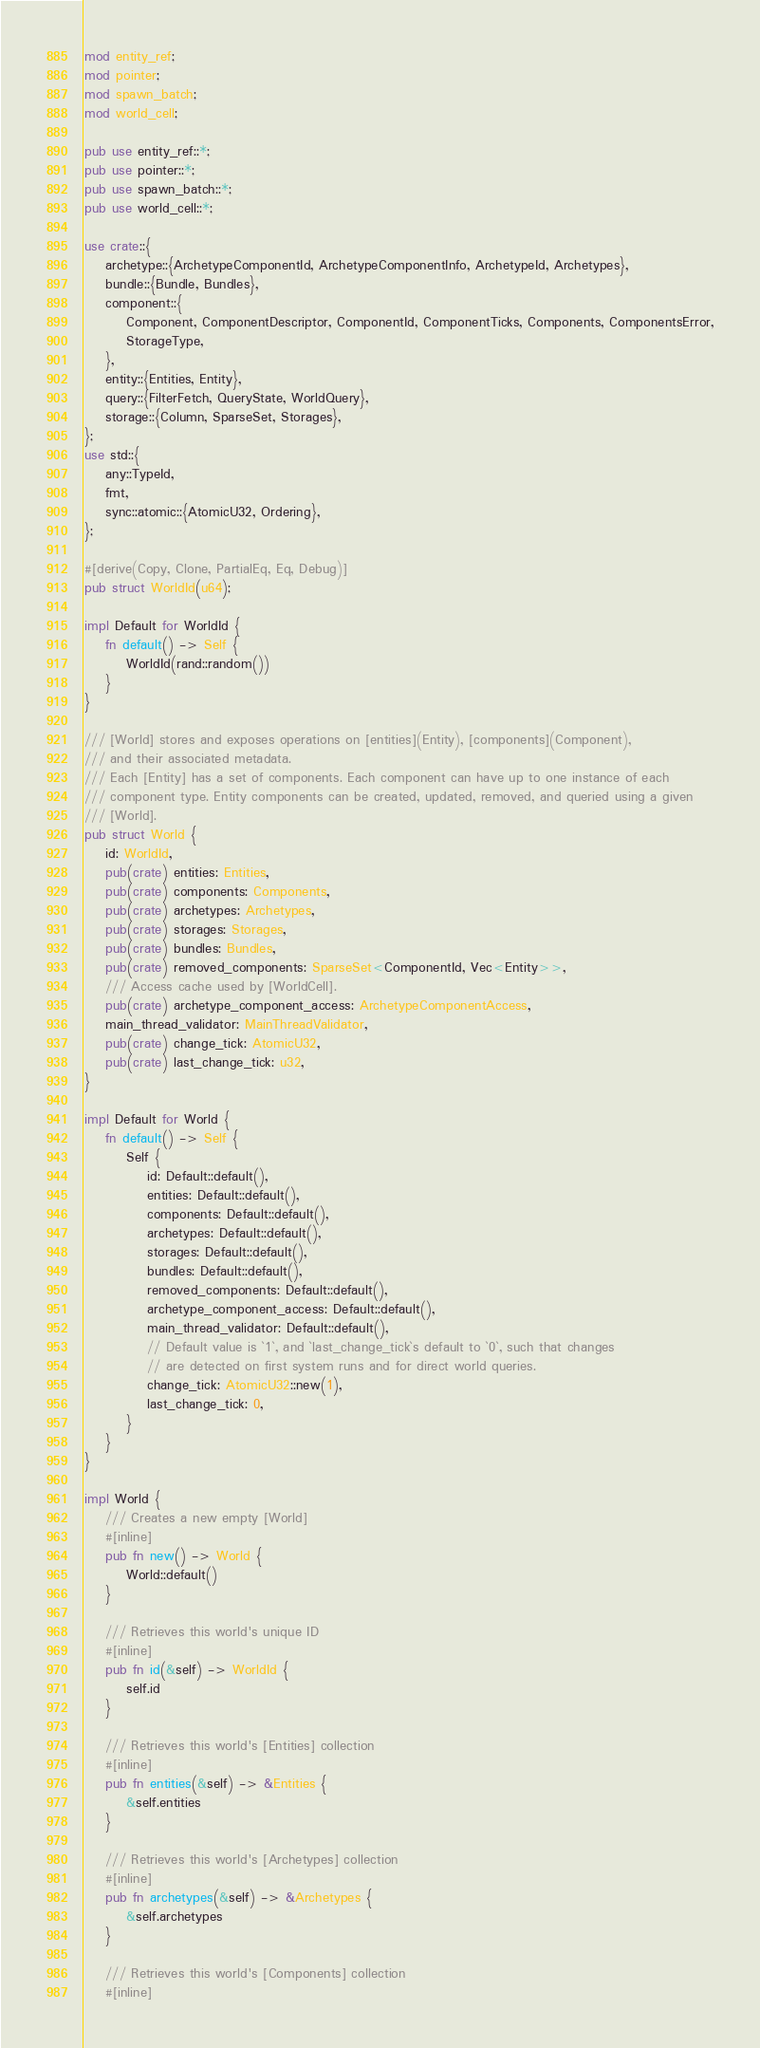<code> <loc_0><loc_0><loc_500><loc_500><_Rust_>mod entity_ref;
mod pointer;
mod spawn_batch;
mod world_cell;

pub use entity_ref::*;
pub use pointer::*;
pub use spawn_batch::*;
pub use world_cell::*;

use crate::{
    archetype::{ArchetypeComponentId, ArchetypeComponentInfo, ArchetypeId, Archetypes},
    bundle::{Bundle, Bundles},
    component::{
        Component, ComponentDescriptor, ComponentId, ComponentTicks, Components, ComponentsError,
        StorageType,
    },
    entity::{Entities, Entity},
    query::{FilterFetch, QueryState, WorldQuery},
    storage::{Column, SparseSet, Storages},
};
use std::{
    any::TypeId,
    fmt,
    sync::atomic::{AtomicU32, Ordering},
};

#[derive(Copy, Clone, PartialEq, Eq, Debug)]
pub struct WorldId(u64);

impl Default for WorldId {
    fn default() -> Self {
        WorldId(rand::random())
    }
}

/// [World] stores and exposes operations on [entities](Entity), [components](Component),
/// and their associated metadata.
/// Each [Entity] has a set of components. Each component can have up to one instance of each
/// component type. Entity components can be created, updated, removed, and queried using a given
/// [World].
pub struct World {
    id: WorldId,
    pub(crate) entities: Entities,
    pub(crate) components: Components,
    pub(crate) archetypes: Archetypes,
    pub(crate) storages: Storages,
    pub(crate) bundles: Bundles,
    pub(crate) removed_components: SparseSet<ComponentId, Vec<Entity>>,
    /// Access cache used by [WorldCell].
    pub(crate) archetype_component_access: ArchetypeComponentAccess,
    main_thread_validator: MainThreadValidator,
    pub(crate) change_tick: AtomicU32,
    pub(crate) last_change_tick: u32,
}

impl Default for World {
    fn default() -> Self {
        Self {
            id: Default::default(),
            entities: Default::default(),
            components: Default::default(),
            archetypes: Default::default(),
            storages: Default::default(),
            bundles: Default::default(),
            removed_components: Default::default(),
            archetype_component_access: Default::default(),
            main_thread_validator: Default::default(),
            // Default value is `1`, and `last_change_tick`s default to `0`, such that changes
            // are detected on first system runs and for direct world queries.
            change_tick: AtomicU32::new(1),
            last_change_tick: 0,
        }
    }
}

impl World {
    /// Creates a new empty [World]
    #[inline]
    pub fn new() -> World {
        World::default()
    }

    /// Retrieves this world's unique ID
    #[inline]
    pub fn id(&self) -> WorldId {
        self.id
    }

    /// Retrieves this world's [Entities] collection
    #[inline]
    pub fn entities(&self) -> &Entities {
        &self.entities
    }

    /// Retrieves this world's [Archetypes] collection
    #[inline]
    pub fn archetypes(&self) -> &Archetypes {
        &self.archetypes
    }

    /// Retrieves this world's [Components] collection
    #[inline]</code> 